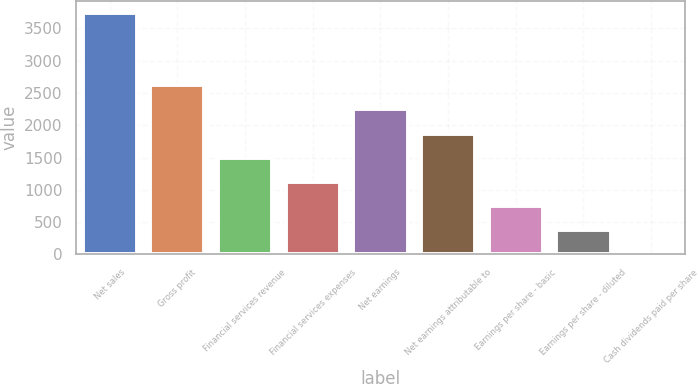<chart> <loc_0><loc_0><loc_500><loc_500><bar_chart><fcel>Net sales<fcel>Gross profit<fcel>Financial services revenue<fcel>Financial services expenses<fcel>Net earnings<fcel>Net earnings attributable to<fcel>Earnings per share - basic<fcel>Earnings per share - diluted<fcel>Cash dividends paid per share<nl><fcel>3740.7<fcel>2619.52<fcel>1498.33<fcel>1124.6<fcel>2245.79<fcel>1872.06<fcel>750.87<fcel>377.14<fcel>3.41<nl></chart> 